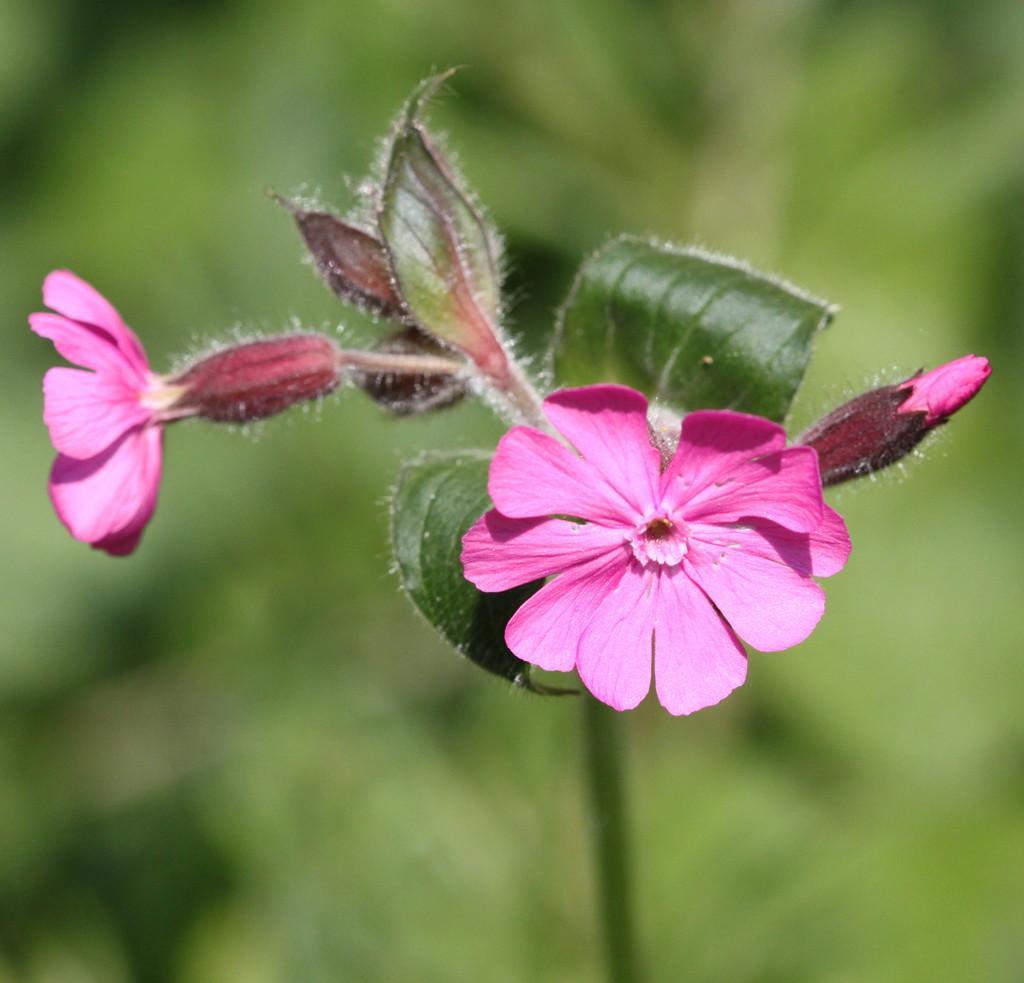In one or two sentences, can you explain what this image depicts? This image consists of a flowers in pink color along with green leaves. The background is blurred. 